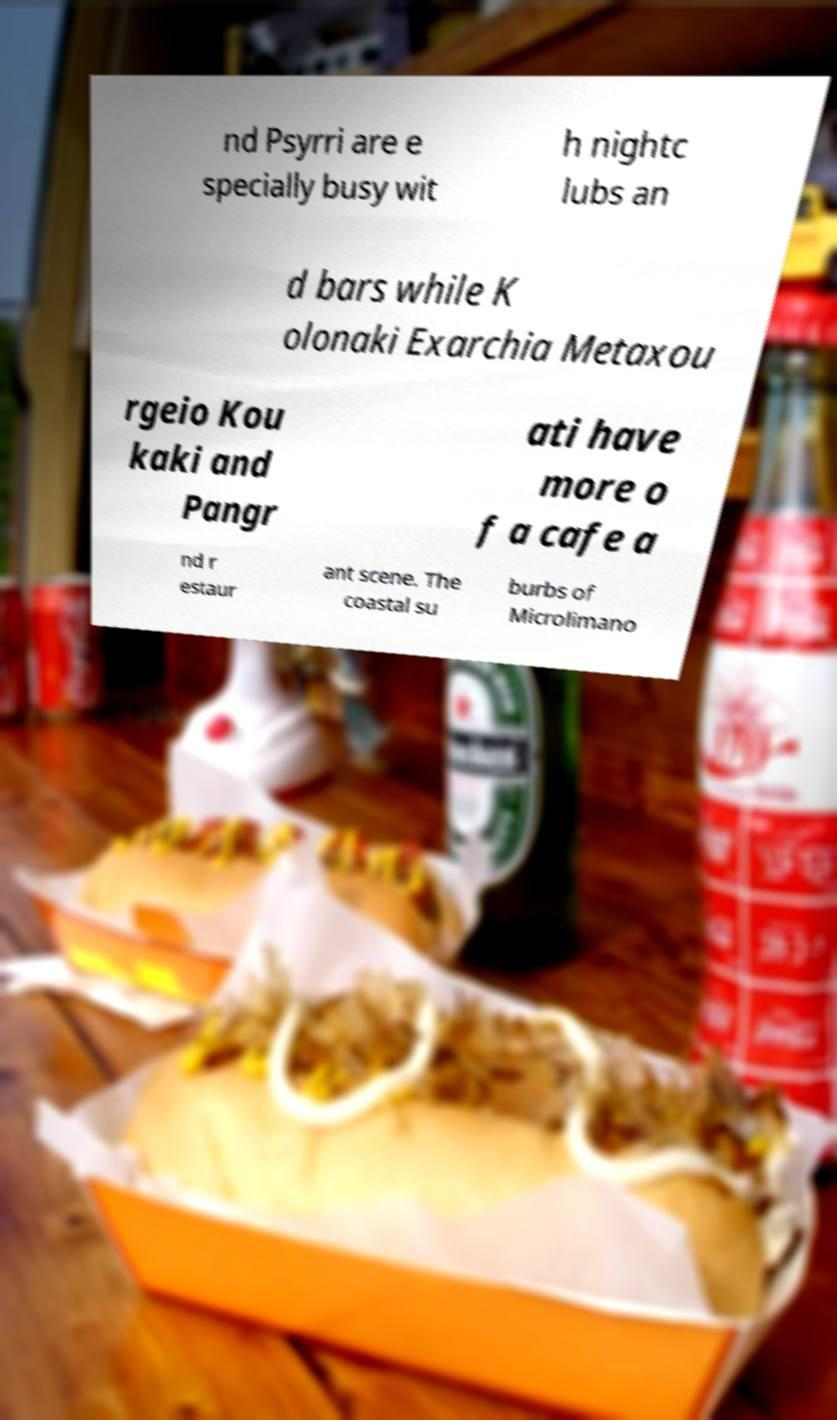Please read and relay the text visible in this image. What does it say? nd Psyrri are e specially busy wit h nightc lubs an d bars while K olonaki Exarchia Metaxou rgeio Kou kaki and Pangr ati have more o f a cafe a nd r estaur ant scene. The coastal su burbs of Microlimano 